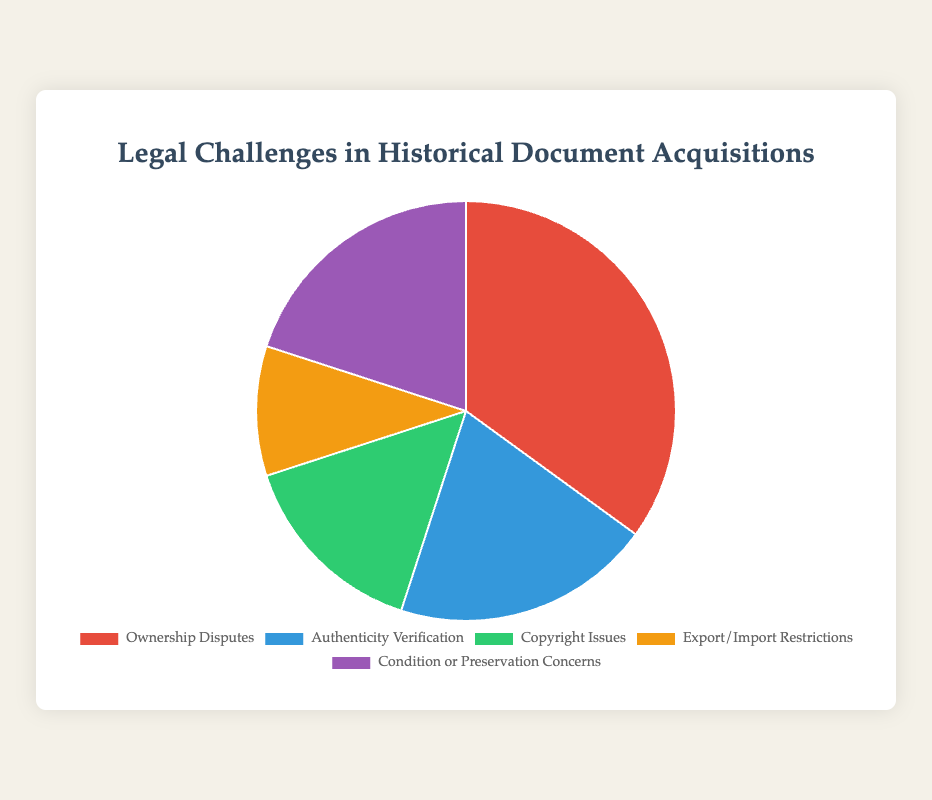What's the largest category among the legal challenges? The largest category is the one with the highest percentage. Ownership Disputes has 35%, which is higher than the other categories.
Answer: Ownership Disputes What's the total percentage for Authenticity Verification and Condition or Preservation Concerns combined? Add the percentages for Authenticity Verification (20%) and Condition or Preservation Concerns (20%): 20% + 20% = 40%
Answer: 40% Which category has a larger percentage: Copyright Issues or Export/Import Restrictions? Compare the percentages for Copyright Issues (15%) and Export/Import Restrictions (10%): 15% > 10%
Answer: Copyright Issues What is the average percentage of the Ownership Disputes, Export/Import Restrictions, and Condition or Preservation Concerns categories? Add the percentages and divide by the number of categories: (35% + 10% + 20%) / 3 = 65% / 3 = ~21.67%
Answer: ~21.67% How much larger is the Ownership Disputes category compared to Copyright Issues? Subtract the percentage of Copyright Issues from the percentage of Ownership Disputes: 35% - 15% = 20%
Answer: 20% Which color represents the Export/Import Restrictions category? The color for Export/Import Restrictions is identified in the pie chart legend. It corresponds to orange.
Answer: Orange What percentage of challenges are related to Authenticity Verification and Condition or Preservation Concerns categories together compared to Ownership Disputes alone? Sum the two percentages (20% for Authenticity Verification and 20% for Condition or Preservation Concerns) and compare to Ownership Disputes (35%): 20% + 20% = 40%, which is greater than 35%
Answer: 40% > 35% If you add another category with 5%, what will be the new total percentage for all categories? The total percentage of the pie chart is always 100%, and adding a new category does not change this. The distribution among categories will adjust, but the total remains 100%.
Answer: 100% 